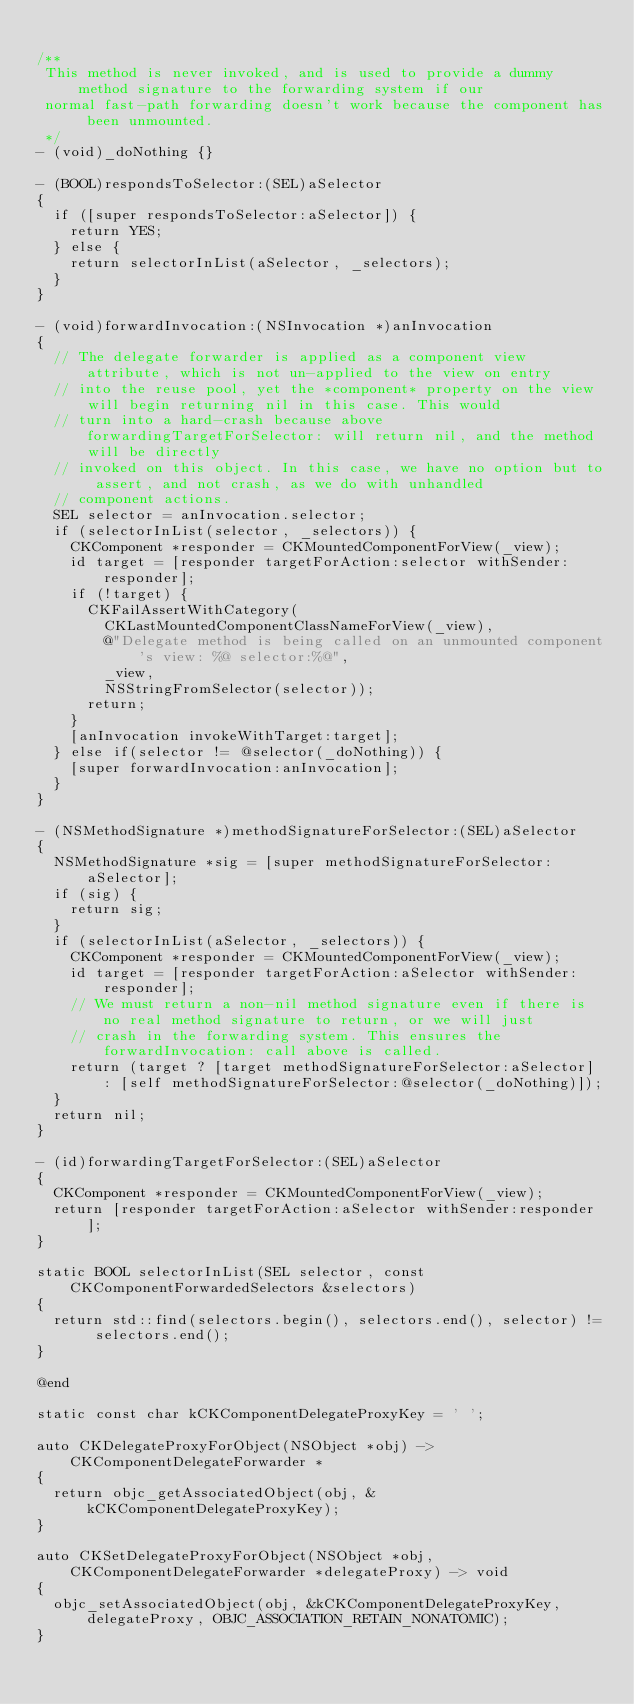<code> <loc_0><loc_0><loc_500><loc_500><_ObjectiveC_>
/**
 This method is never invoked, and is used to provide a dummy method signature to the forwarding system if our
 normal fast-path forwarding doesn't work because the component has been unmounted.
 */
- (void)_doNothing {}

- (BOOL)respondsToSelector:(SEL)aSelector
{
  if ([super respondsToSelector:aSelector]) {
    return YES;
  } else {
    return selectorInList(aSelector, _selectors);
  }
}

- (void)forwardInvocation:(NSInvocation *)anInvocation
{
  // The delegate forwarder is applied as a component view attribute, which is not un-applied to the view on entry
  // into the reuse pool, yet the *component* property on the view will begin returning nil in this case. This would
  // turn into a hard-crash because above forwardingTargetForSelector: will return nil, and the method will be directly
  // invoked on this object. In this case, we have no option but to assert, and not crash, as we do with unhandled
  // component actions.
  SEL selector = anInvocation.selector;
  if (selectorInList(selector, _selectors)) {
    CKComponent *responder = CKMountedComponentForView(_view);
    id target = [responder targetForAction:selector withSender:responder];
    if (!target) {
      CKFailAssertWithCategory(
        CKLastMountedComponentClassNameForView(_view),
        @"Delegate method is being called on an unmounted component's view: %@ selector:%@", 
        _view,
        NSStringFromSelector(selector));
      return;
    }
    [anInvocation invokeWithTarget:target];
  } else if(selector != @selector(_doNothing)) {
    [super forwardInvocation:anInvocation];
  }
}

- (NSMethodSignature *)methodSignatureForSelector:(SEL)aSelector
{
  NSMethodSignature *sig = [super methodSignatureForSelector:aSelector];
  if (sig) {
    return sig;
  }
  if (selectorInList(aSelector, _selectors)) {
    CKComponent *responder = CKMountedComponentForView(_view);
    id target = [responder targetForAction:aSelector withSender:responder];
    // We must return a non-nil method signature even if there is no real method signature to return, or we will just
    // crash in the forwarding system. This ensures the forwardInvocation: call above is called.
    return (target ? [target methodSignatureForSelector:aSelector] : [self methodSignatureForSelector:@selector(_doNothing)]);
  }
  return nil;
}

- (id)forwardingTargetForSelector:(SEL)aSelector
{
  CKComponent *responder = CKMountedComponentForView(_view);
  return [responder targetForAction:aSelector withSender:responder];
}

static BOOL selectorInList(SEL selector, const CKComponentForwardedSelectors &selectors)
{
  return std::find(selectors.begin(), selectors.end(), selector) != selectors.end();
}

@end

static const char kCKComponentDelegateProxyKey = ' ';

auto CKDelegateProxyForObject(NSObject *obj) -> CKComponentDelegateForwarder *
{
  return objc_getAssociatedObject(obj, &kCKComponentDelegateProxyKey);
}

auto CKSetDelegateProxyForObject(NSObject *obj, CKComponentDelegateForwarder *delegateProxy) -> void
{
  objc_setAssociatedObject(obj, &kCKComponentDelegateProxyKey, delegateProxy, OBJC_ASSOCIATION_RETAIN_NONATOMIC);
}
</code> 